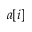<formula> <loc_0><loc_0><loc_500><loc_500>a [ i ]</formula> 